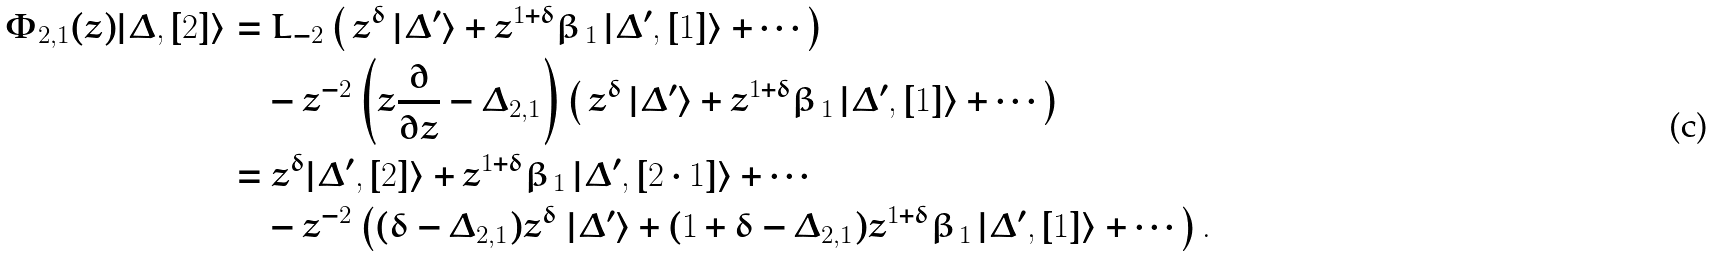Convert formula to latex. <formula><loc_0><loc_0><loc_500><loc_500>\Phi _ { 2 , 1 } ( z ) | \Delta , [ 2 ] \rangle & = L _ { - 2 } \left ( \, z ^ { \delta } \, | \Delta ^ { \prime } \rangle + z ^ { 1 + \delta } \beta _ { \, 1 } \, | \Delta ^ { \prime } , [ 1 ] \rangle + \cdots \right ) \\ & \quad - z ^ { - 2 } \left ( z \frac { \partial } { \partial z } - \Delta _ { 2 , 1 } \right ) \left ( \, z ^ { \delta } \, | \Delta ^ { \prime } \rangle + z ^ { 1 + \delta } \beta _ { \, 1 } \, | \Delta ^ { \prime } , [ 1 ] \rangle + \cdots \right ) \\ & = z ^ { \delta } | \Delta ^ { \prime } , [ 2 ] \rangle + z ^ { 1 + \delta } \beta _ { \, 1 } \, | \Delta ^ { \prime } , [ 2 \cdot 1 ] \rangle + \cdots \\ & \quad - z ^ { - 2 } \left ( ( \delta - \Delta _ { 2 , 1 } ) z ^ { \delta } \ | \Delta ^ { \prime } \rangle + ( 1 + \delta - \Delta _ { 2 , 1 } ) z ^ { 1 + \delta } \beta _ { \, 1 } \, | \Delta ^ { \prime } , [ 1 ] \rangle + \cdots \right ) .</formula> 